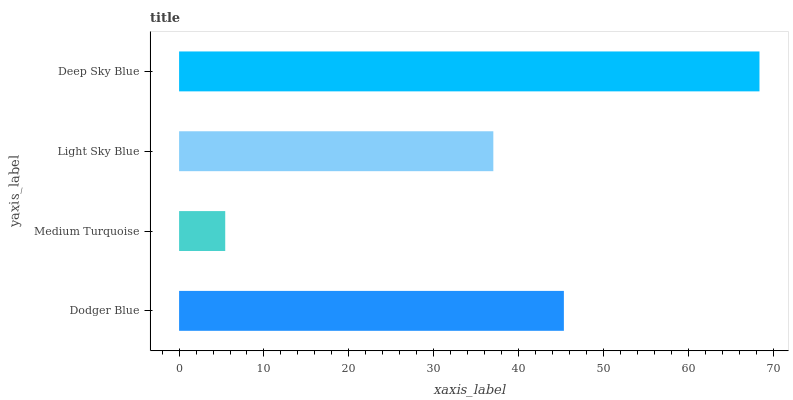Is Medium Turquoise the minimum?
Answer yes or no. Yes. Is Deep Sky Blue the maximum?
Answer yes or no. Yes. Is Light Sky Blue the minimum?
Answer yes or no. No. Is Light Sky Blue the maximum?
Answer yes or no. No. Is Light Sky Blue greater than Medium Turquoise?
Answer yes or no. Yes. Is Medium Turquoise less than Light Sky Blue?
Answer yes or no. Yes. Is Medium Turquoise greater than Light Sky Blue?
Answer yes or no. No. Is Light Sky Blue less than Medium Turquoise?
Answer yes or no. No. Is Dodger Blue the high median?
Answer yes or no. Yes. Is Light Sky Blue the low median?
Answer yes or no. Yes. Is Light Sky Blue the high median?
Answer yes or no. No. Is Deep Sky Blue the low median?
Answer yes or no. No. 